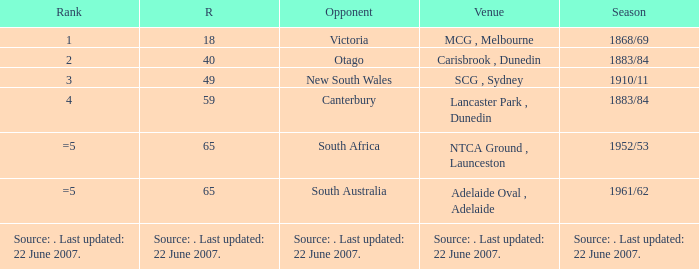Which Run has an Opponent of Canterbury? 59.0. 